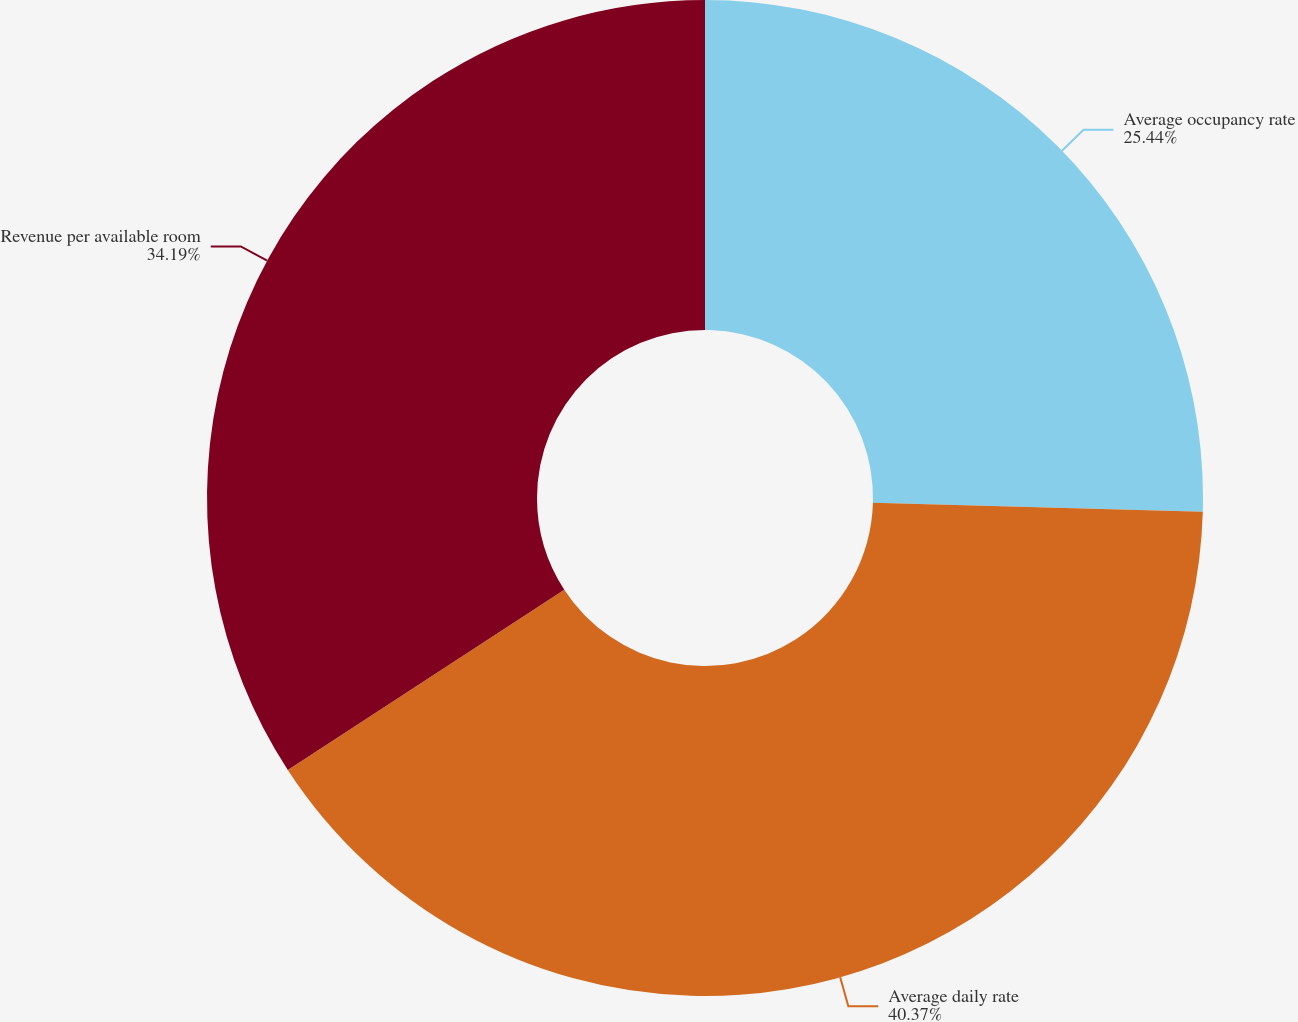Convert chart to OTSL. <chart><loc_0><loc_0><loc_500><loc_500><pie_chart><fcel>Average occupancy rate<fcel>Average daily rate<fcel>Revenue per available room<nl><fcel>25.44%<fcel>40.36%<fcel>34.19%<nl></chart> 